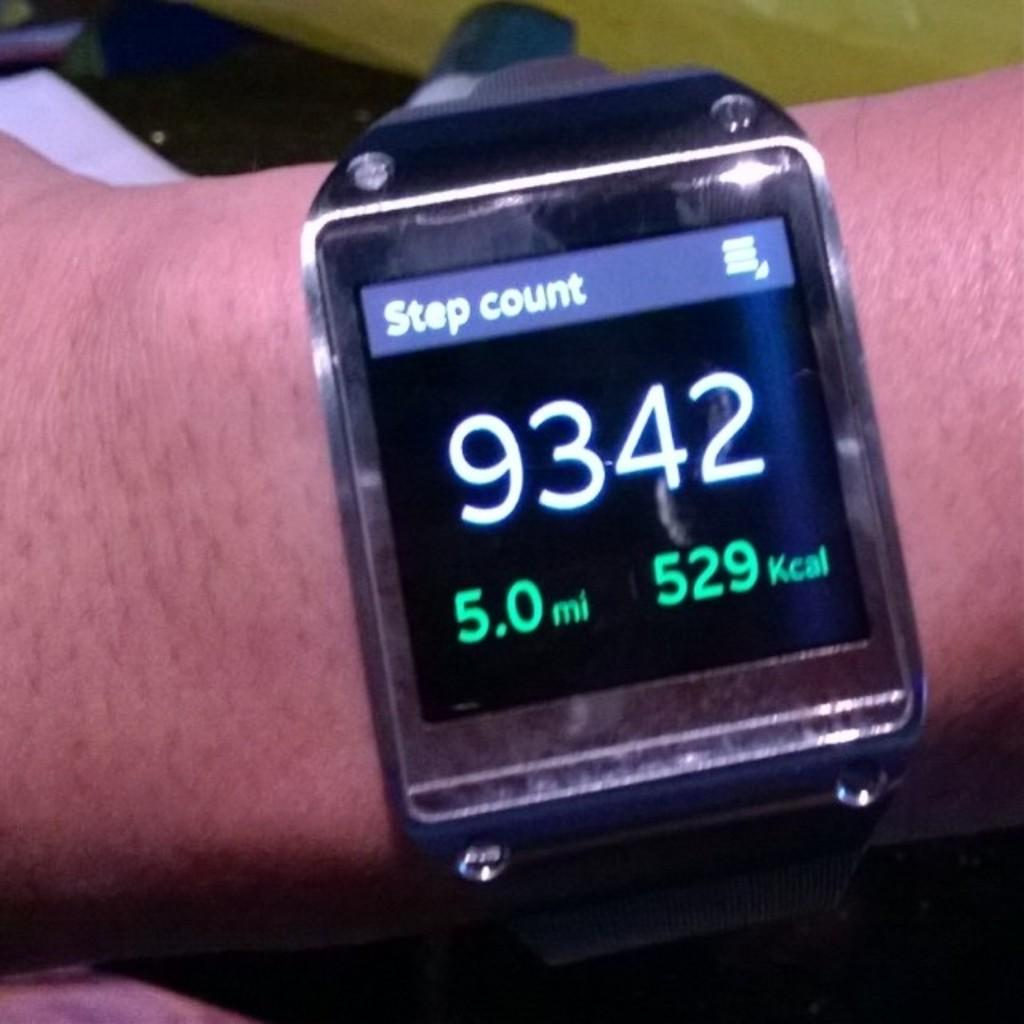<image>
Relay a brief, clear account of the picture shown. A sports watch that says Step count in white letters on a blue background. 